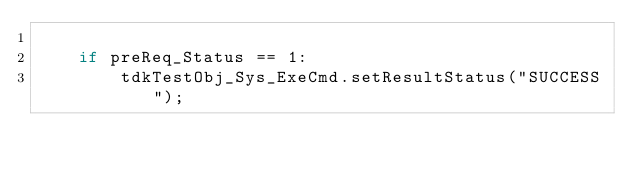Convert code to text. <code><loc_0><loc_0><loc_500><loc_500><_Python_>
    if preReq_Status == 1:
        tdkTestObj_Sys_ExeCmd.setResultStatus("SUCCESS");
</code> 